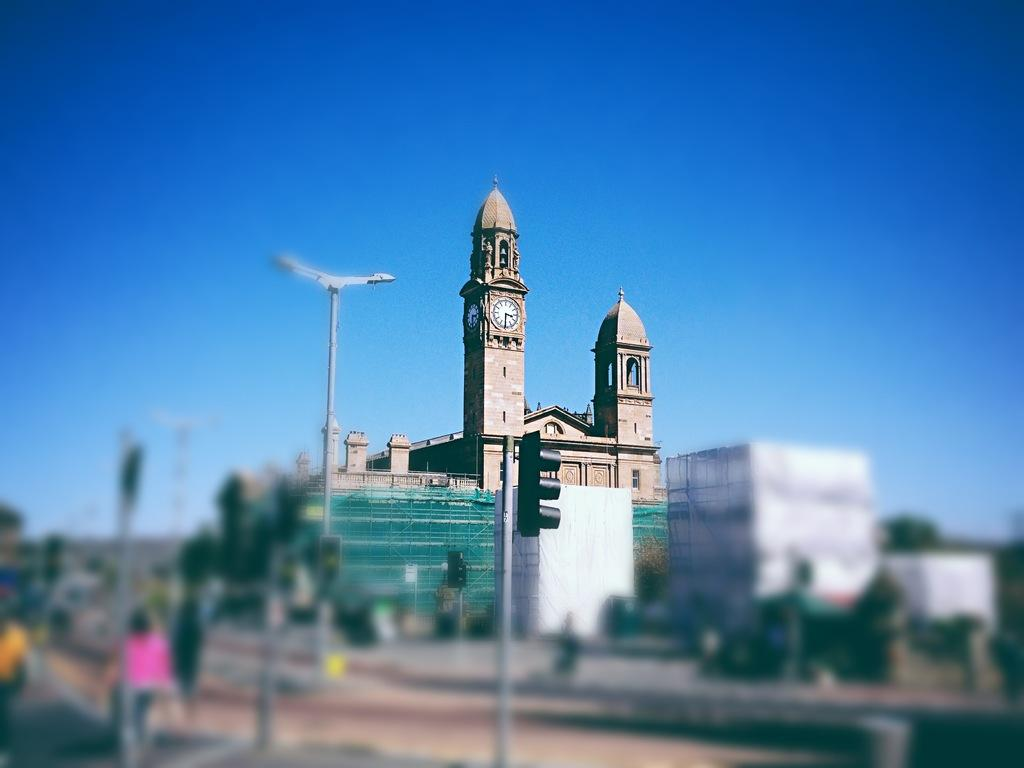What is the main structure in the middle of the image? There is a clock tower in the middle of the image. What is located at the bottom of the image? There is a signal at the bottom of the image. What can be seen at the top of the image? The sky is visible at the top of the image. What type of bottle is being used for treatment in the image? There is no bottle or treatment present in the image. What kind of noise can be heard coming from the clock tower in the image? The image is static, so no noise can be heard from the clock tower. 